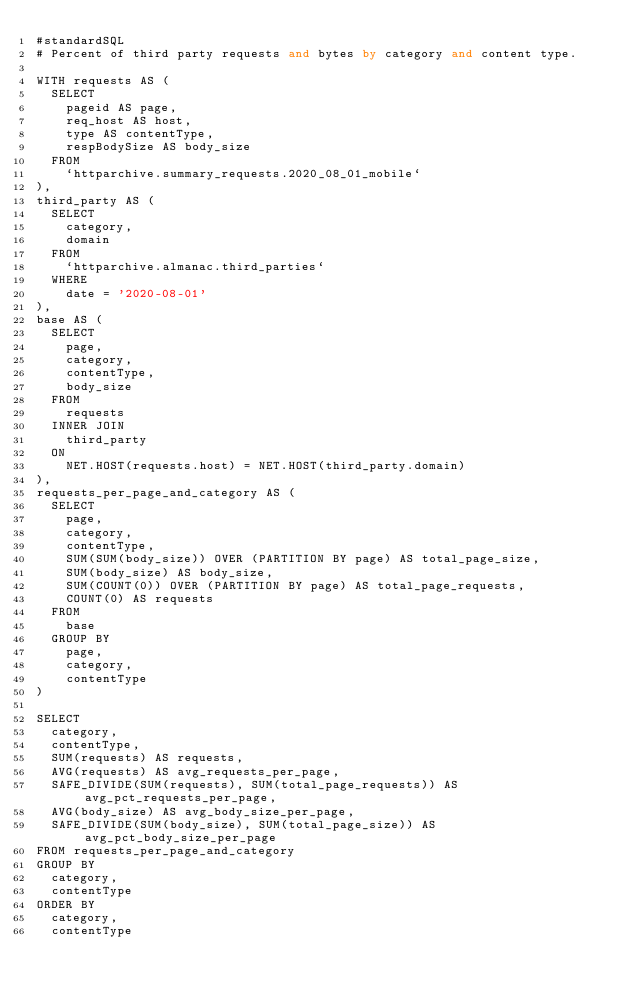Convert code to text. <code><loc_0><loc_0><loc_500><loc_500><_SQL_>#standardSQL
# Percent of third party requests and bytes by category and content type.

WITH requests AS (
  SELECT
    pageid AS page,
    req_host AS host,
    type AS contentType,
    respBodySize AS body_size
  FROM
    `httparchive.summary_requests.2020_08_01_mobile`
),
third_party AS (
  SELECT
    category,
    domain
  FROM
    `httparchive.almanac.third_parties`
  WHERE
    date = '2020-08-01'
),
base AS (
  SELECT
    page,
    category,
    contentType,
    body_size
  FROM
    requests
  INNER JOIN
    third_party
  ON
    NET.HOST(requests.host) = NET.HOST(third_party.domain)
),
requests_per_page_and_category AS (
  SELECT
    page,
    category,
    contentType,
    SUM(SUM(body_size)) OVER (PARTITION BY page) AS total_page_size,
    SUM(body_size) AS body_size,
    SUM(COUNT(0)) OVER (PARTITION BY page) AS total_page_requests,
    COUNT(0) AS requests
  FROM
    base
  GROUP BY
    page,
    category,
    contentType
)

SELECT
  category,
  contentType,
  SUM(requests) AS requests,
  AVG(requests) AS avg_requests_per_page,
  SAFE_DIVIDE(SUM(requests), SUM(total_page_requests)) AS avg_pct_requests_per_page,
  AVG(body_size) AS avg_body_size_per_page,
  SAFE_DIVIDE(SUM(body_size), SUM(total_page_size)) AS avg_pct_body_size_per_page
FROM requests_per_page_and_category
GROUP BY
  category,
  contentType
ORDER BY
  category,
  contentType
</code> 